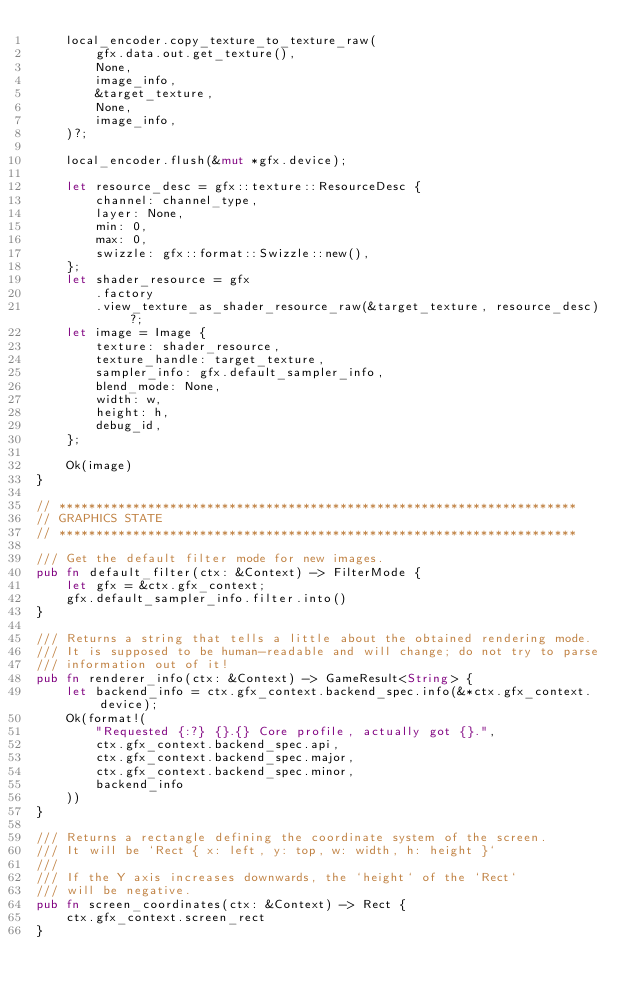Convert code to text. <code><loc_0><loc_0><loc_500><loc_500><_Rust_>    local_encoder.copy_texture_to_texture_raw(
        gfx.data.out.get_texture(),
        None,
        image_info,
        &target_texture,
        None,
        image_info,
    )?;

    local_encoder.flush(&mut *gfx.device);

    let resource_desc = gfx::texture::ResourceDesc {
        channel: channel_type,
        layer: None,
        min: 0,
        max: 0,
        swizzle: gfx::format::Swizzle::new(),
    };
    let shader_resource = gfx
        .factory
        .view_texture_as_shader_resource_raw(&target_texture, resource_desc)?;
    let image = Image {
        texture: shader_resource,
        texture_handle: target_texture,
        sampler_info: gfx.default_sampler_info,
        blend_mode: None,
        width: w,
        height: h,
        debug_id,
    };

    Ok(image)
}

// **********************************************************************
// GRAPHICS STATE
// **********************************************************************

/// Get the default filter mode for new images.
pub fn default_filter(ctx: &Context) -> FilterMode {
    let gfx = &ctx.gfx_context;
    gfx.default_sampler_info.filter.into()
}

/// Returns a string that tells a little about the obtained rendering mode.
/// It is supposed to be human-readable and will change; do not try to parse
/// information out of it!
pub fn renderer_info(ctx: &Context) -> GameResult<String> {
    let backend_info = ctx.gfx_context.backend_spec.info(&*ctx.gfx_context.device);
    Ok(format!(
        "Requested {:?} {}.{} Core profile, actually got {}.",
        ctx.gfx_context.backend_spec.api,
        ctx.gfx_context.backend_spec.major,
        ctx.gfx_context.backend_spec.minor,
        backend_info
    ))
}

/// Returns a rectangle defining the coordinate system of the screen.
/// It will be `Rect { x: left, y: top, w: width, h: height }`
///
/// If the Y axis increases downwards, the `height` of the `Rect`
/// will be negative.
pub fn screen_coordinates(ctx: &Context) -> Rect {
    ctx.gfx_context.screen_rect
}
</code> 